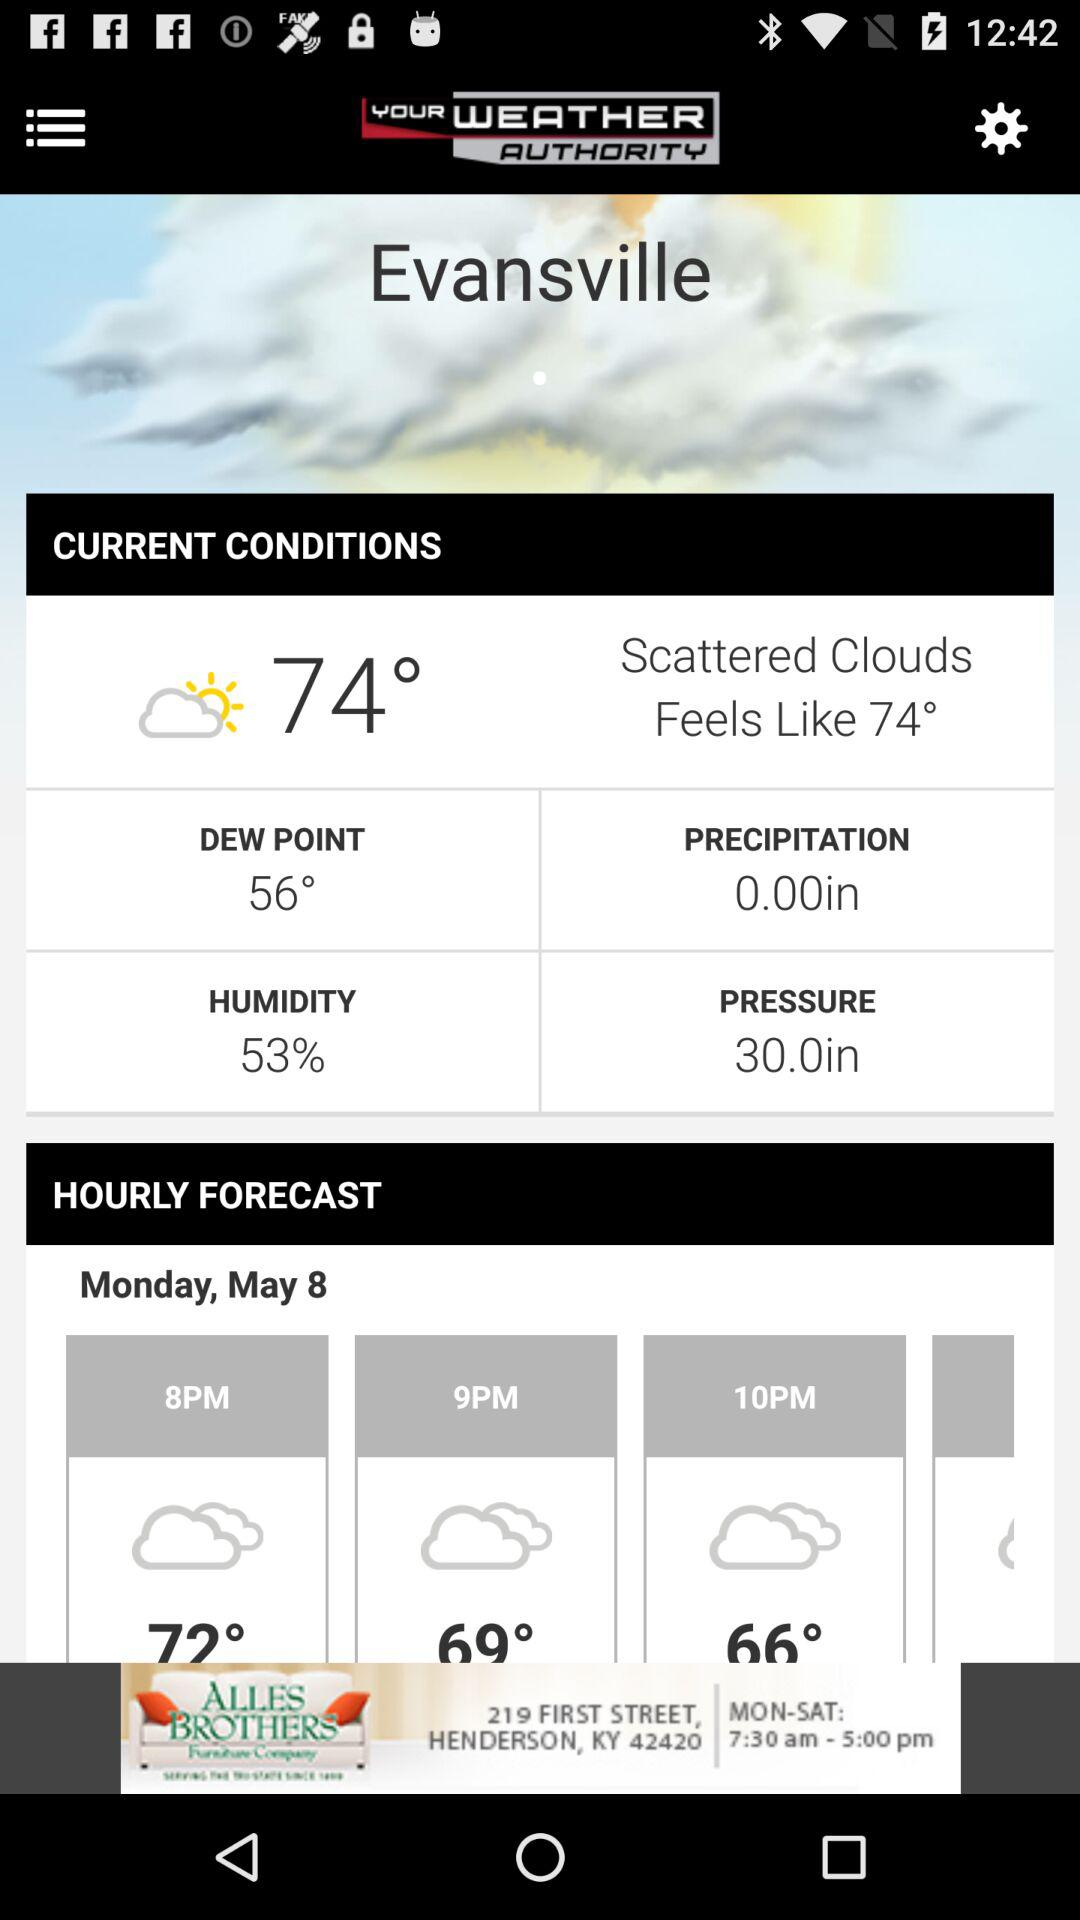What is the current pressure? The current pressure is 30 inches. 